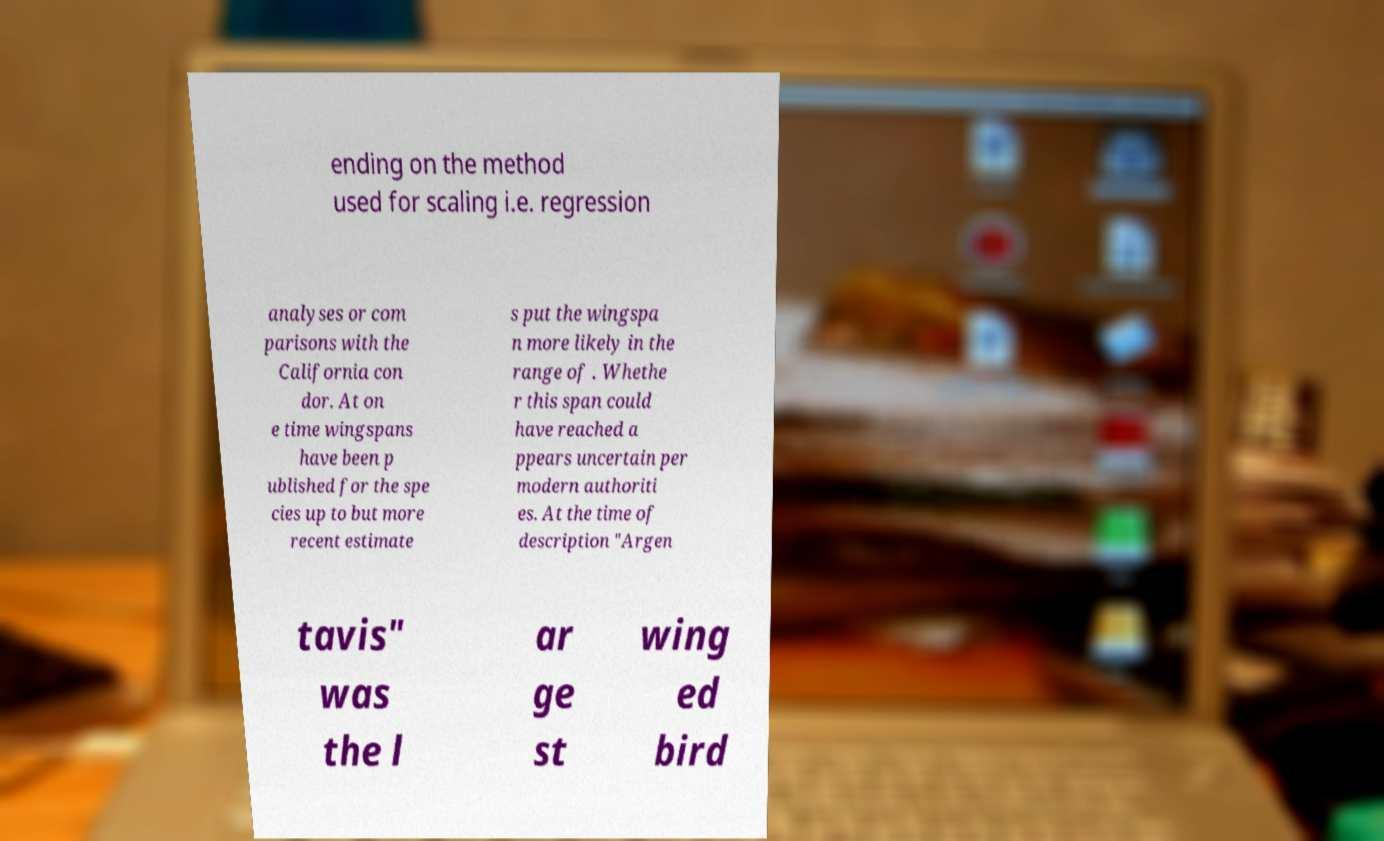For documentation purposes, I need the text within this image transcribed. Could you provide that? ending on the method used for scaling i.e. regression analyses or com parisons with the California con dor. At on e time wingspans have been p ublished for the spe cies up to but more recent estimate s put the wingspa n more likely in the range of . Whethe r this span could have reached a ppears uncertain per modern authoriti es. At the time of description "Argen tavis" was the l ar ge st wing ed bird 